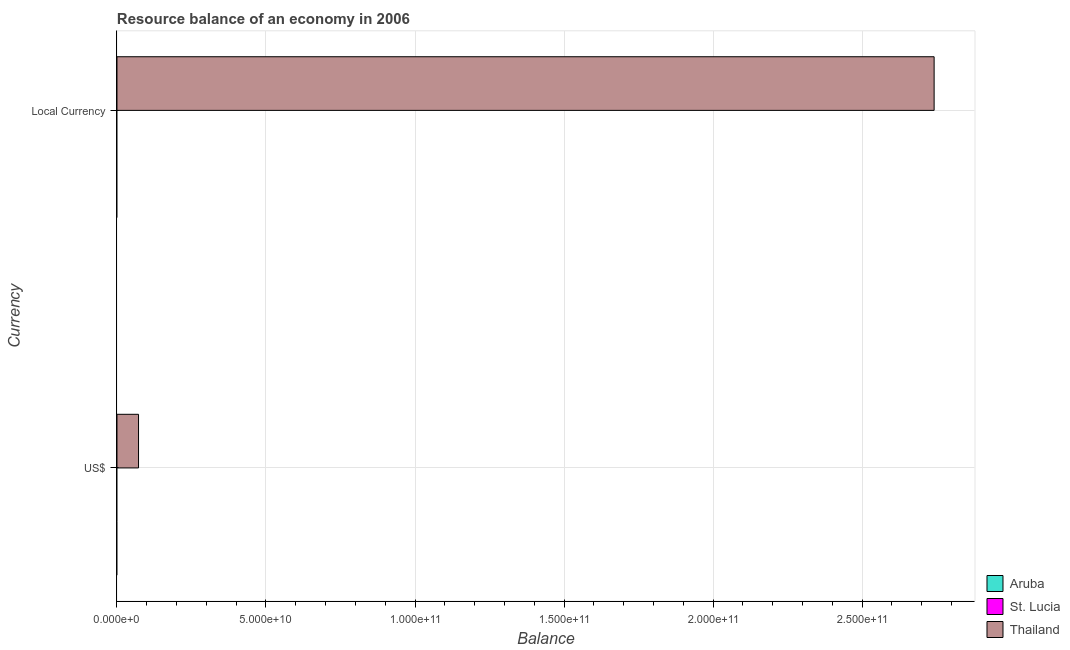How many bars are there on the 2nd tick from the top?
Ensure brevity in your answer.  1. How many bars are there on the 1st tick from the bottom?
Keep it short and to the point. 1. What is the label of the 1st group of bars from the top?
Your response must be concise. Local Currency. Across all countries, what is the maximum resource balance in constant us$?
Your answer should be compact. 2.74e+11. Across all countries, what is the minimum resource balance in us$?
Make the answer very short. 0. In which country was the resource balance in us$ maximum?
Your response must be concise. Thailand. What is the total resource balance in constant us$ in the graph?
Your answer should be very brief. 2.74e+11. What is the average resource balance in constant us$ per country?
Keep it short and to the point. 9.14e+1. What is the difference between the resource balance in us$ and resource balance in constant us$ in Thailand?
Ensure brevity in your answer.  -2.67e+11. In how many countries, is the resource balance in us$ greater than 80000000000 units?
Make the answer very short. 0. In how many countries, is the resource balance in constant us$ greater than the average resource balance in constant us$ taken over all countries?
Offer a terse response. 1. Are all the bars in the graph horizontal?
Ensure brevity in your answer.  Yes. How many countries are there in the graph?
Give a very brief answer. 3. Are the values on the major ticks of X-axis written in scientific E-notation?
Keep it short and to the point. Yes. Does the graph contain any zero values?
Offer a very short reply. Yes. How many legend labels are there?
Offer a very short reply. 3. What is the title of the graph?
Your answer should be compact. Resource balance of an economy in 2006. Does "Israel" appear as one of the legend labels in the graph?
Offer a very short reply. No. What is the label or title of the X-axis?
Your answer should be very brief. Balance. What is the label or title of the Y-axis?
Make the answer very short. Currency. What is the Balance of Aruba in US$?
Offer a terse response. 0. What is the Balance in St. Lucia in US$?
Give a very brief answer. 0. What is the Balance of Thailand in US$?
Provide a short and direct response. 7.24e+09. What is the Balance of St. Lucia in Local Currency?
Your answer should be very brief. 0. What is the Balance in Thailand in Local Currency?
Make the answer very short. 2.74e+11. Across all Currency, what is the maximum Balance of Thailand?
Ensure brevity in your answer.  2.74e+11. Across all Currency, what is the minimum Balance of Thailand?
Your answer should be very brief. 7.24e+09. What is the total Balance of St. Lucia in the graph?
Give a very brief answer. 0. What is the total Balance of Thailand in the graph?
Provide a succinct answer. 2.81e+11. What is the difference between the Balance in Thailand in US$ and that in Local Currency?
Provide a succinct answer. -2.67e+11. What is the average Balance of Aruba per Currency?
Your answer should be very brief. 0. What is the average Balance of St. Lucia per Currency?
Offer a very short reply. 0. What is the average Balance of Thailand per Currency?
Give a very brief answer. 1.41e+11. What is the ratio of the Balance in Thailand in US$ to that in Local Currency?
Make the answer very short. 0.03. What is the difference between the highest and the second highest Balance in Thailand?
Ensure brevity in your answer.  2.67e+11. What is the difference between the highest and the lowest Balance in Thailand?
Your response must be concise. 2.67e+11. 